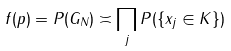<formula> <loc_0><loc_0><loc_500><loc_500>f ( p ) = P ( G _ { N } ) \asymp \prod _ { j } P ( \{ x _ { j } \in K \} )</formula> 